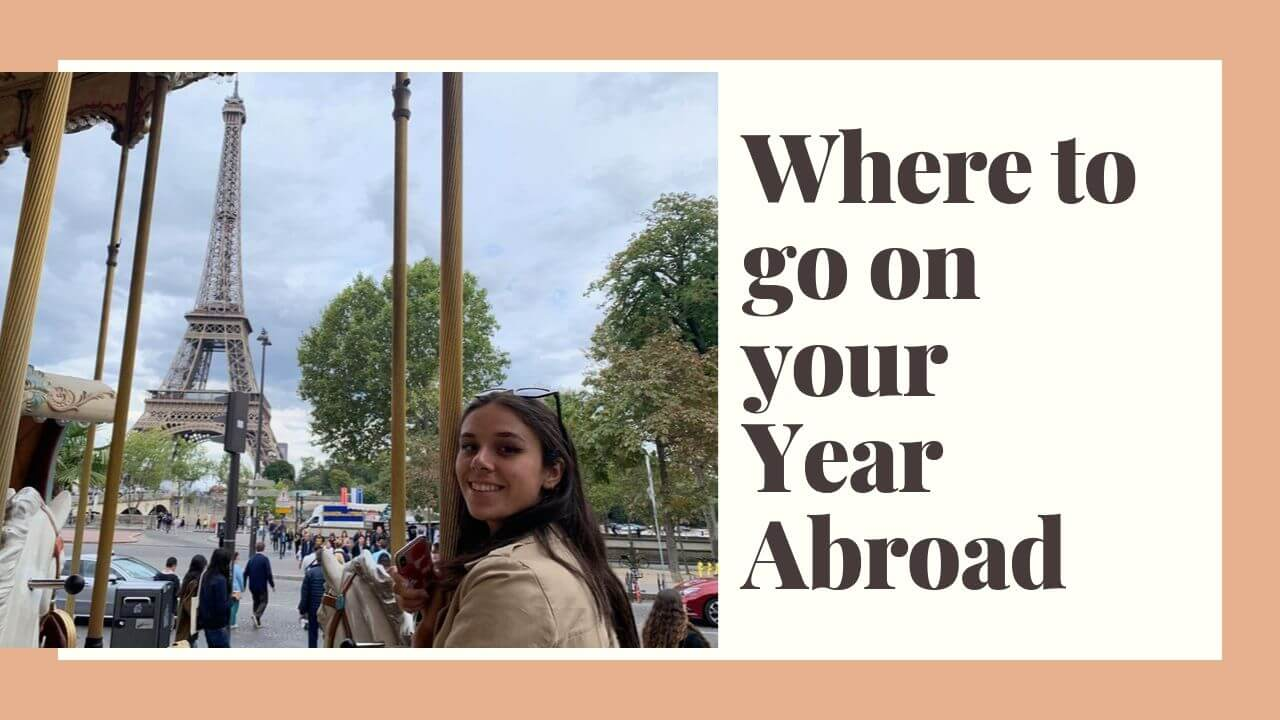If this image were part of a story, what might the plot be? If this image were part of a story, it might depict the journey of a young woman embarking on her first adventure abroad. She decides to spend a year in Paris, where she explores iconic landmarks, immerses herself in the local culture, and makes unforgettable memories. The story would follow her as she navigates the joys and challenges of living in a foreign city, making new friends, and growing personally and academically throughout her year-long adventure. 